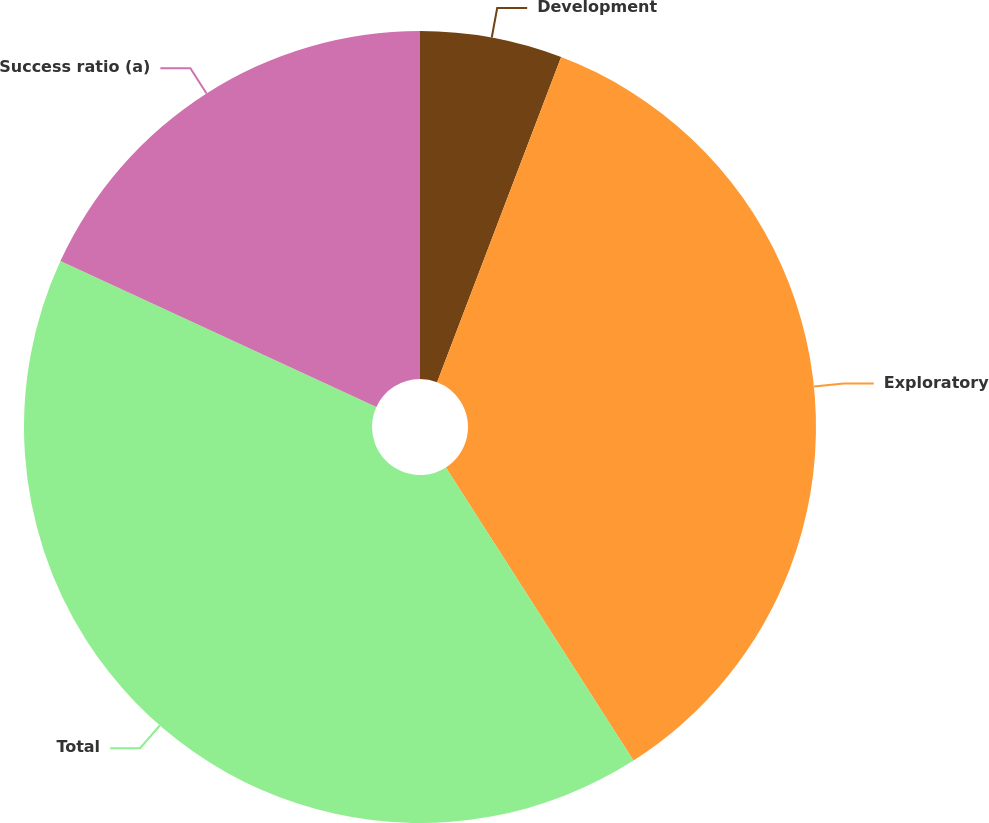Convert chart. <chart><loc_0><loc_0><loc_500><loc_500><pie_chart><fcel>Development<fcel>Exploratory<fcel>Total<fcel>Success ratio (a)<nl><fcel>5.8%<fcel>35.14%<fcel>40.94%<fcel>18.12%<nl></chart> 